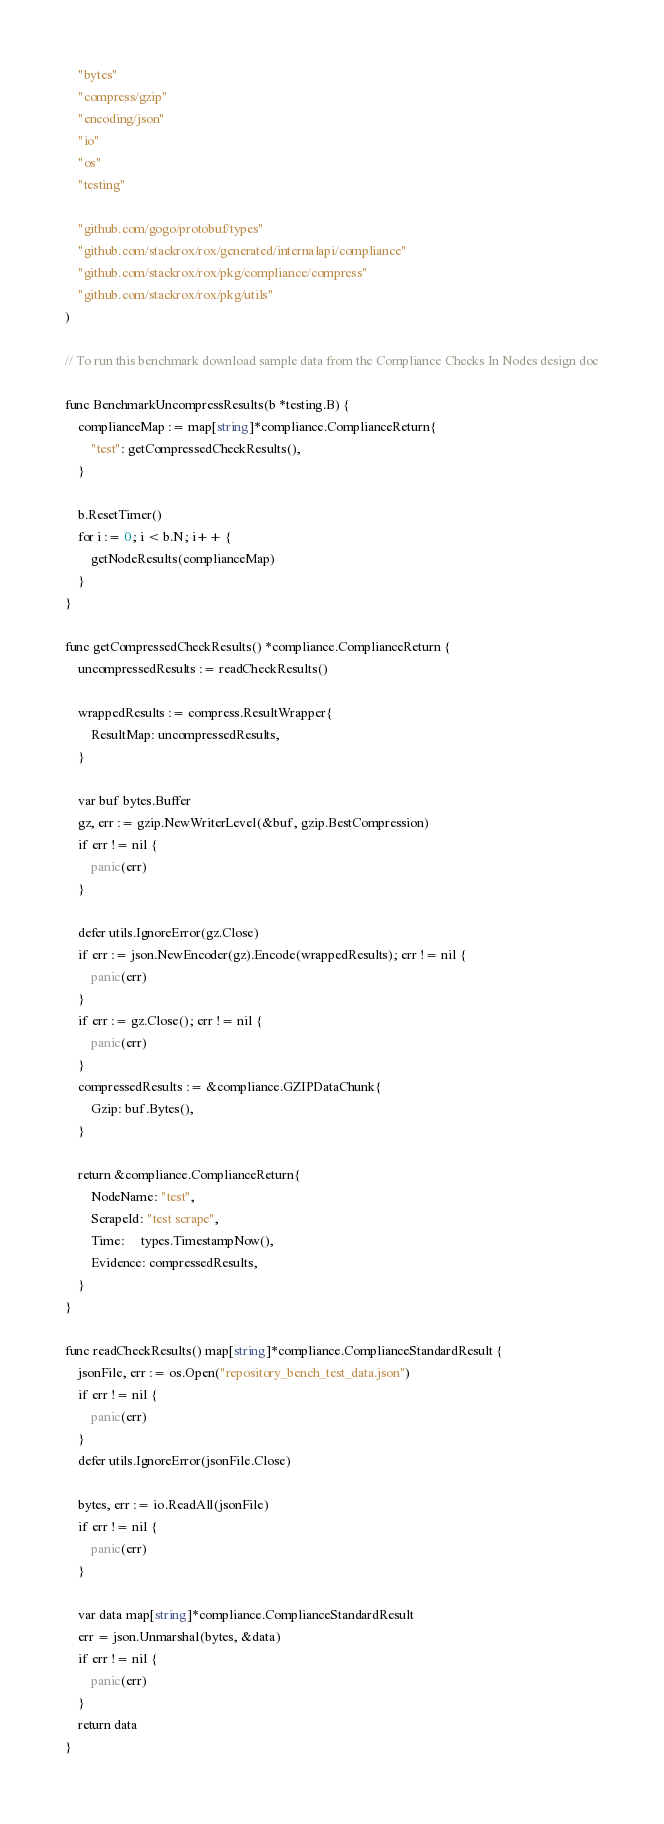<code> <loc_0><loc_0><loc_500><loc_500><_Go_>	"bytes"
	"compress/gzip"
	"encoding/json"
	"io"
	"os"
	"testing"

	"github.com/gogo/protobuf/types"
	"github.com/stackrox/rox/generated/internalapi/compliance"
	"github.com/stackrox/rox/pkg/compliance/compress"
	"github.com/stackrox/rox/pkg/utils"
)

// To run this benchmark download sample data from the Compliance Checks In Nodes design doc

func BenchmarkUncompressResults(b *testing.B) {
	complianceMap := map[string]*compliance.ComplianceReturn{
		"test": getCompressedCheckResults(),
	}

	b.ResetTimer()
	for i := 0; i < b.N; i++ {
		getNodeResults(complianceMap)
	}
}

func getCompressedCheckResults() *compliance.ComplianceReturn {
	uncompressedResults := readCheckResults()

	wrappedResults := compress.ResultWrapper{
		ResultMap: uncompressedResults,
	}

	var buf bytes.Buffer
	gz, err := gzip.NewWriterLevel(&buf, gzip.BestCompression)
	if err != nil {
		panic(err)
	}

	defer utils.IgnoreError(gz.Close)
	if err := json.NewEncoder(gz).Encode(wrappedResults); err != nil {
		panic(err)
	}
	if err := gz.Close(); err != nil {
		panic(err)
	}
	compressedResults := &compliance.GZIPDataChunk{
		Gzip: buf.Bytes(),
	}

	return &compliance.ComplianceReturn{
		NodeName: "test",
		ScrapeId: "test scrape",
		Time:     types.TimestampNow(),
		Evidence: compressedResults,
	}
}

func readCheckResults() map[string]*compliance.ComplianceStandardResult {
	jsonFile, err := os.Open("repository_bench_test_data.json")
	if err != nil {
		panic(err)
	}
	defer utils.IgnoreError(jsonFile.Close)

	bytes, err := io.ReadAll(jsonFile)
	if err != nil {
		panic(err)
	}

	var data map[string]*compliance.ComplianceStandardResult
	err = json.Unmarshal(bytes, &data)
	if err != nil {
		panic(err)
	}
	return data
}
</code> 